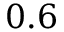Convert formula to latex. <formula><loc_0><loc_0><loc_500><loc_500>0 . 6</formula> 